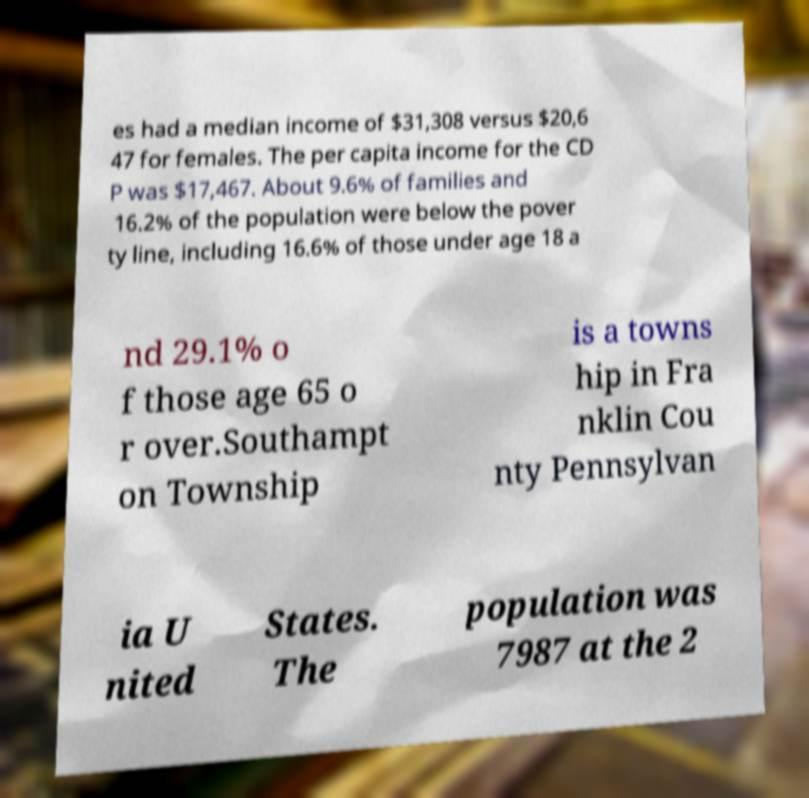Can you read and provide the text displayed in the image?This photo seems to have some interesting text. Can you extract and type it out for me? es had a median income of $31,308 versus $20,6 47 for females. The per capita income for the CD P was $17,467. About 9.6% of families and 16.2% of the population were below the pover ty line, including 16.6% of those under age 18 a nd 29.1% o f those age 65 o r over.Southampt on Township is a towns hip in Fra nklin Cou nty Pennsylvan ia U nited States. The population was 7987 at the 2 